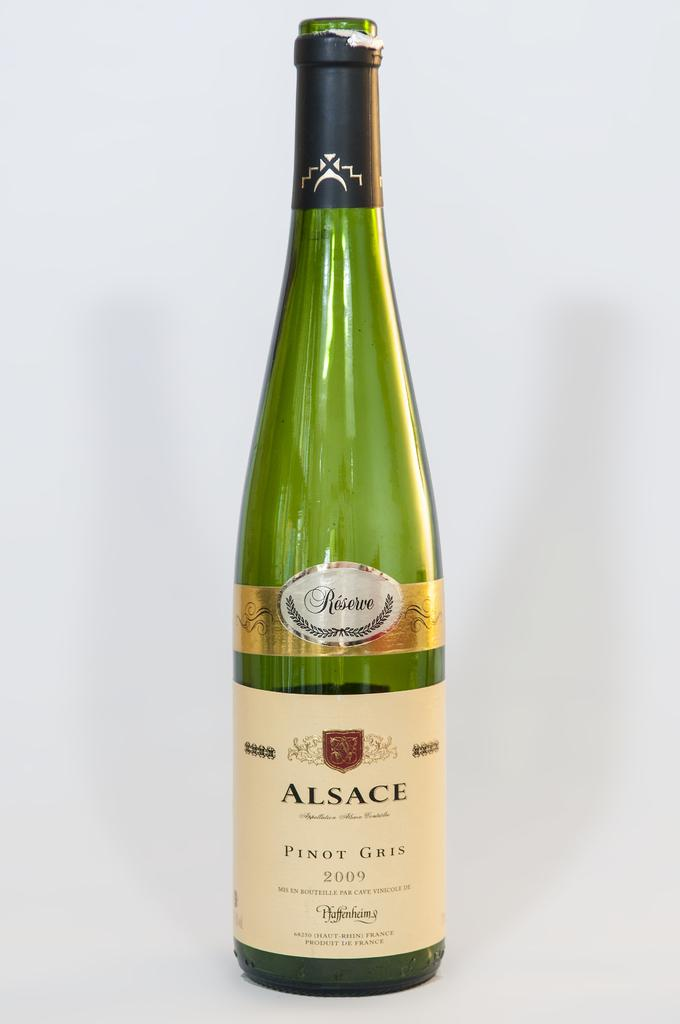Provide a one-sentence caption for the provided image. A bottle of Pinot Gris wine was made in the year 2009. 